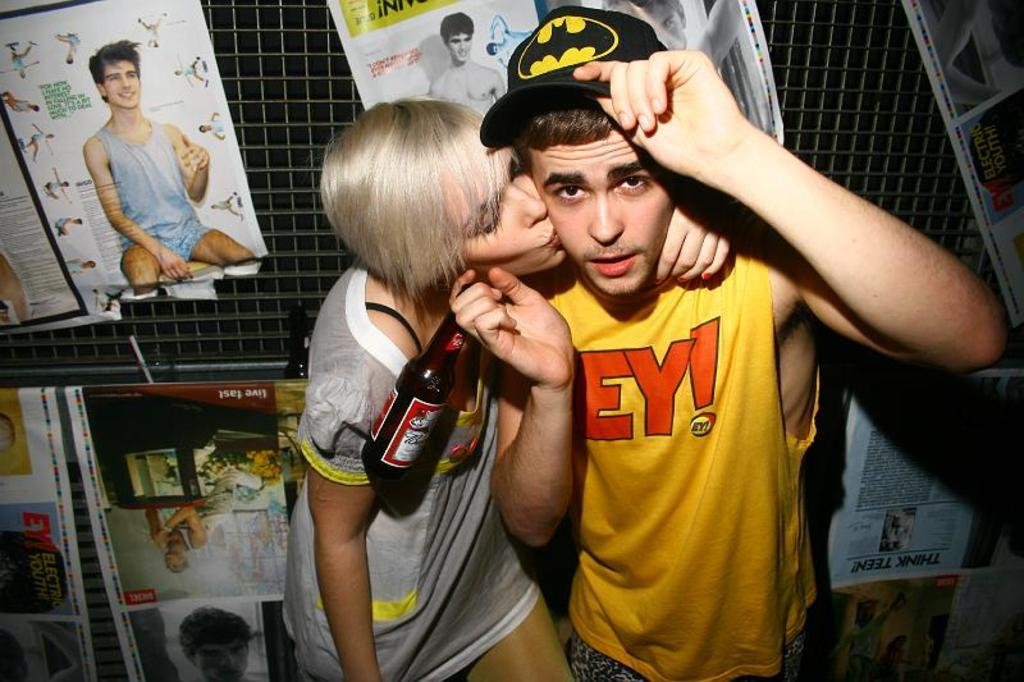How many people are in the image? There are two people in the image, a woman and a man. What is the man holding in the image? The man is holding a bottle in the image. What type of clothing is the man wearing on his head? The man is wearing a cap in the image. What can be seen in the background of the image? There is a fence and posters in the background of the image. What color is the silver cushion in the image? There is no silver cushion present in the image. Is the sleet visible in the image? There is no sleet present in the image. 